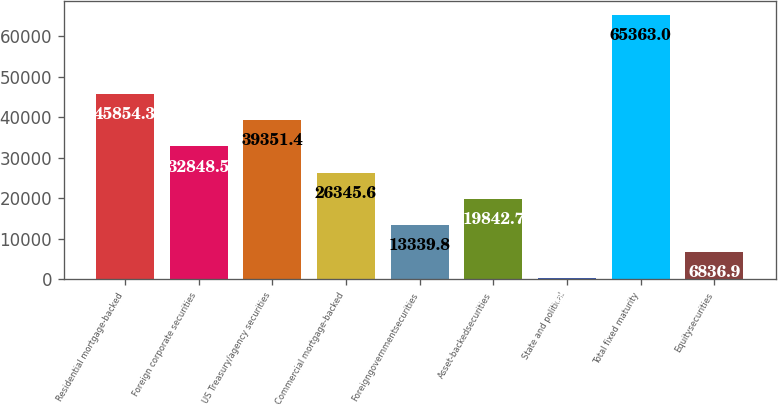Convert chart to OTSL. <chart><loc_0><loc_0><loc_500><loc_500><bar_chart><fcel>Residential mortgage-backed<fcel>Foreign corporate securities<fcel>US Treasury/agency securities<fcel>Commercial mortgage-backed<fcel>Foreigngovernmentsecurities<fcel>Asset-backedsecurities<fcel>State and political<fcel>Total fixed maturity<fcel>Equitysecurities<nl><fcel>45854.3<fcel>32848.5<fcel>39351.4<fcel>26345.6<fcel>13339.8<fcel>19842.7<fcel>334<fcel>65363<fcel>6836.9<nl></chart> 